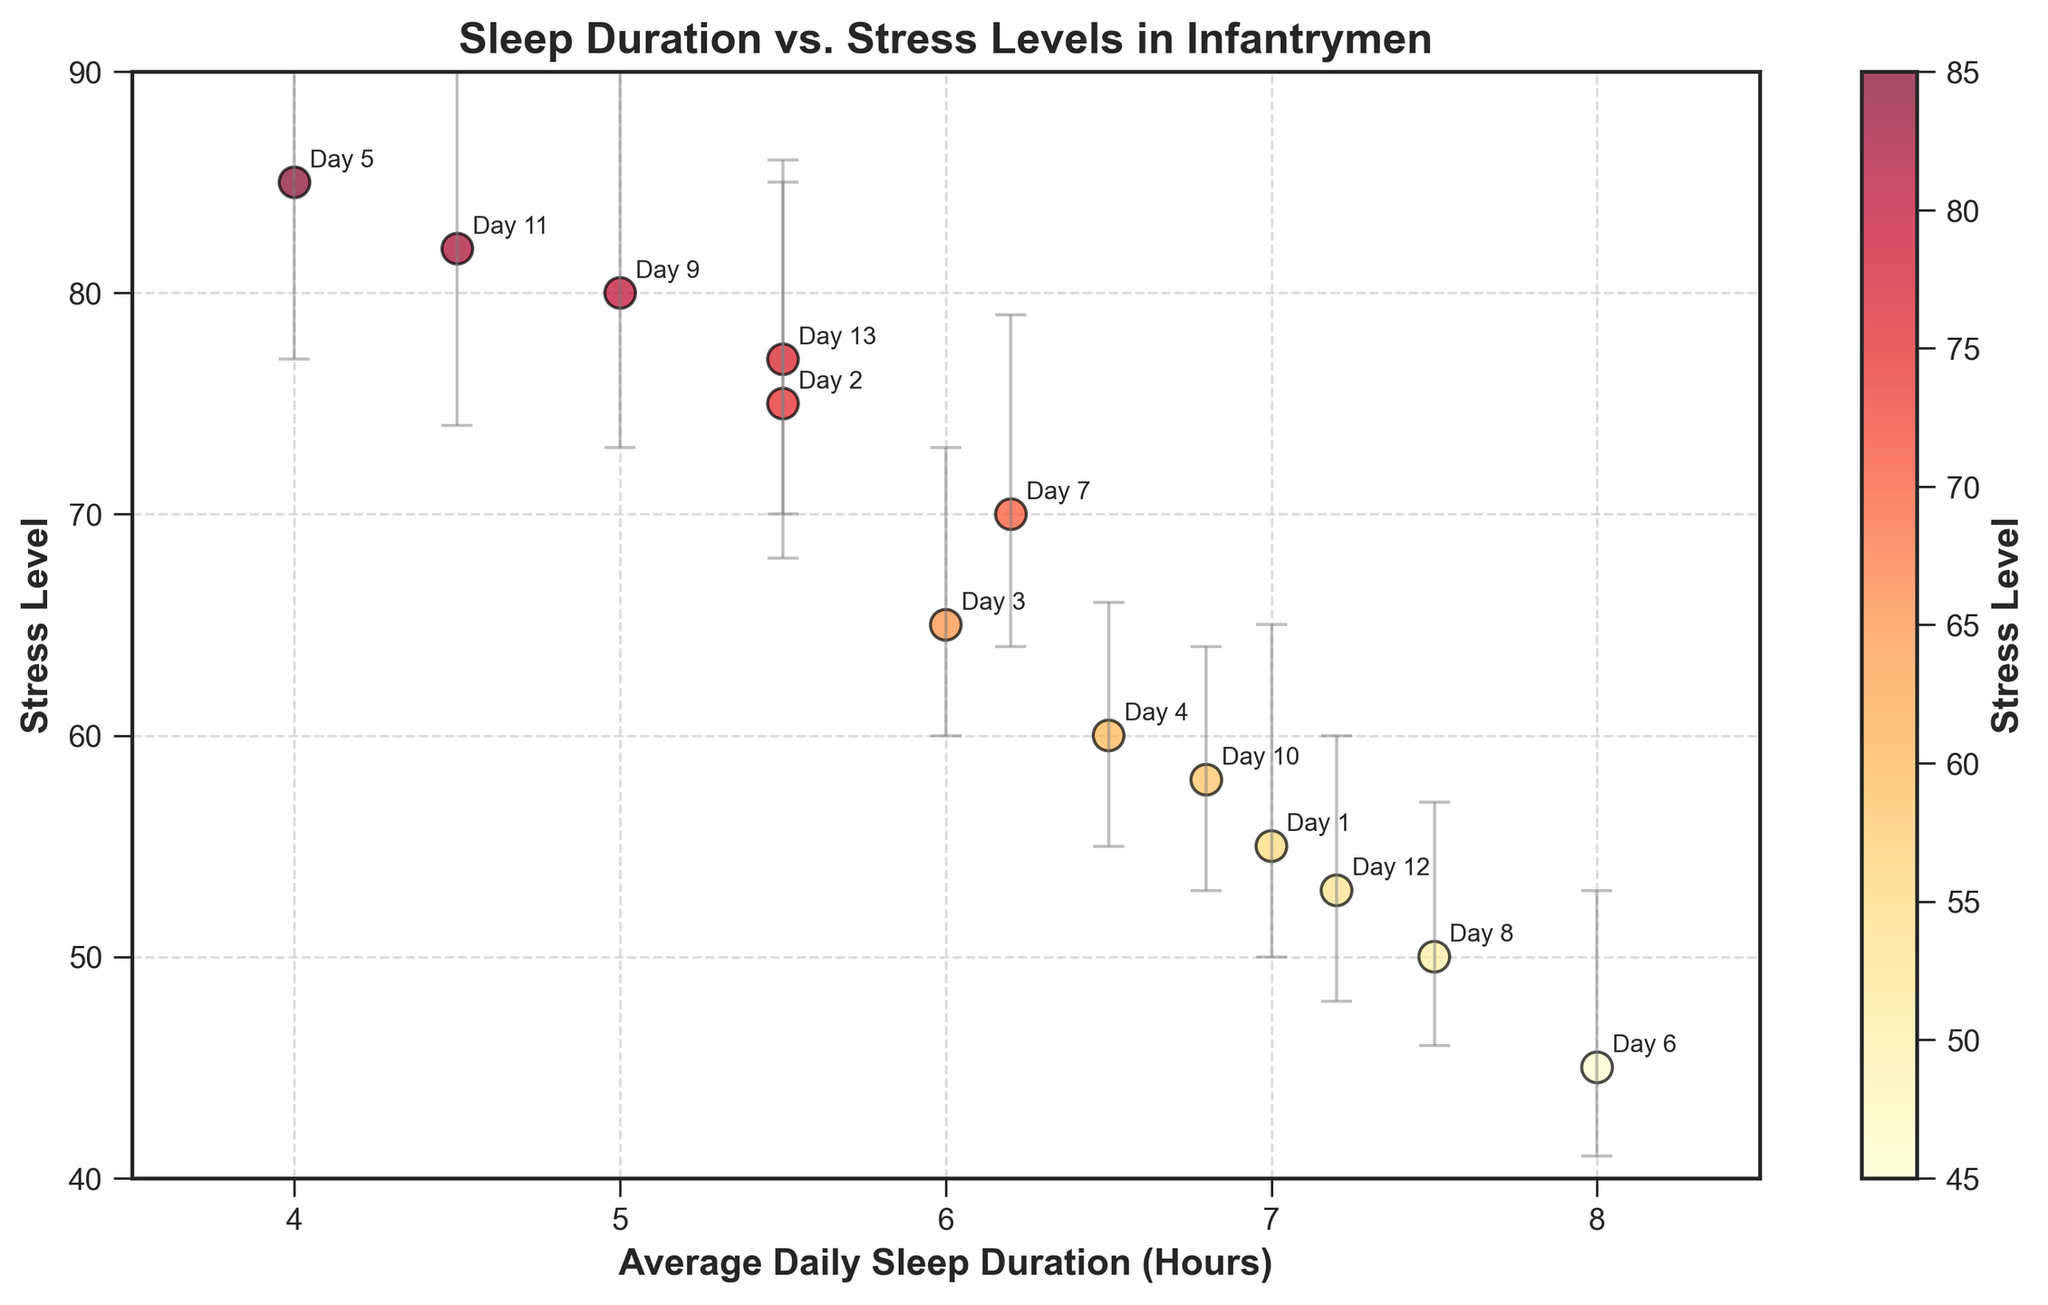What is the title of the figure? The title is usually placed at the top of the figure, prominently displayed, to give an overview of what the figure is about.
Answer: Sleep Duration vs. Stress Levels in Infantrymen How many data points are shown in the plot? The data points are represented by the dots on the plot, and they can be counted visually.
Answer: 13 What does the color gradient in the scatter plot indicate? The color gradient is often indicated by a color bar, which shows the range of values it represents. Here, it is labeled "Stress Level."
Answer: Stress Level Which data point has the highest stress level and what is it? By looking at the vertical axis (Stress Level) and finding the highest point on the scatter plot, we see the data point at the highest stress level.
Answer: 85 What is the average daily sleep duration for the data point with the lowest stress level? To find the lowest stress level on the plot, look at the color bar or find the lowest point on the y-axis and check the corresponding x-axis value.
Answer: 8.0 hours How does stress level generally change with average daily sleep duration? Observing the trend in the scatter plot, we can see the overall direction of the data points as sleep duration increases or decreases.
Answer: Stress level generally decreases with higher average daily sleep duration What are the upper and lower error margins for the data point with 6 hours of average daily sleep duration? Finding the data point at 6 hours on the x-axis and checking the error bars given for it.
Answer: Lower: 5, Upper: 8 Compare the stress levels for data points with average daily sleep durations of 5.5 hours and 7.5 hours. First, find the data points at 5.5 and 7.5 hours on the x-axis and compare their respective y-values.
Answer: 75 (5.5 hours), 50 (7.5 hours) What is the range of average daily sleep duration in the dataset? The range can be determined by finding the minimum and maximum values on the x-axis of the scatter plot.
Answer: 4.0 to 8.0 hours Which data point has the largest error margin and what is it? Locating the data point with the longest error bars by visually comparing all the error bars in the plot.
Answer: 4.0 hours (Error margin: 4 – 12) 